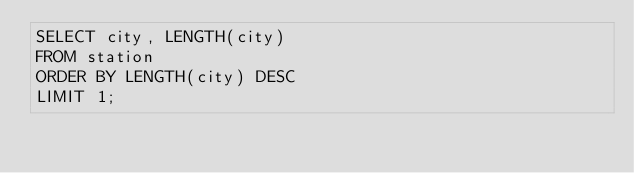<code> <loc_0><loc_0><loc_500><loc_500><_SQL_>SELECT city, LENGTH(city)
FROM station
ORDER BY LENGTH(city) DESC
LIMIT 1;</code> 